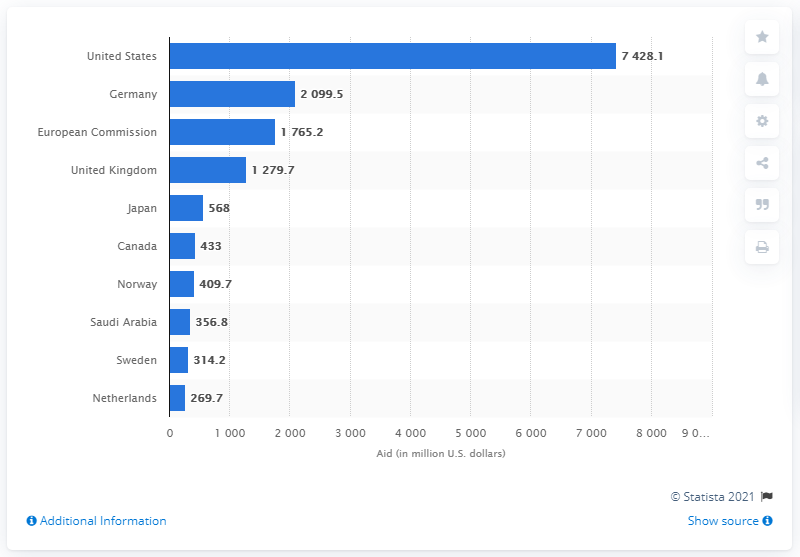Highlight a few significant elements in this photo. In 2020, Germany donated a total of 2099.5 million euros in humanitarian aid. The United States donated $7428.1 million in humanitarian aid in 2020. 